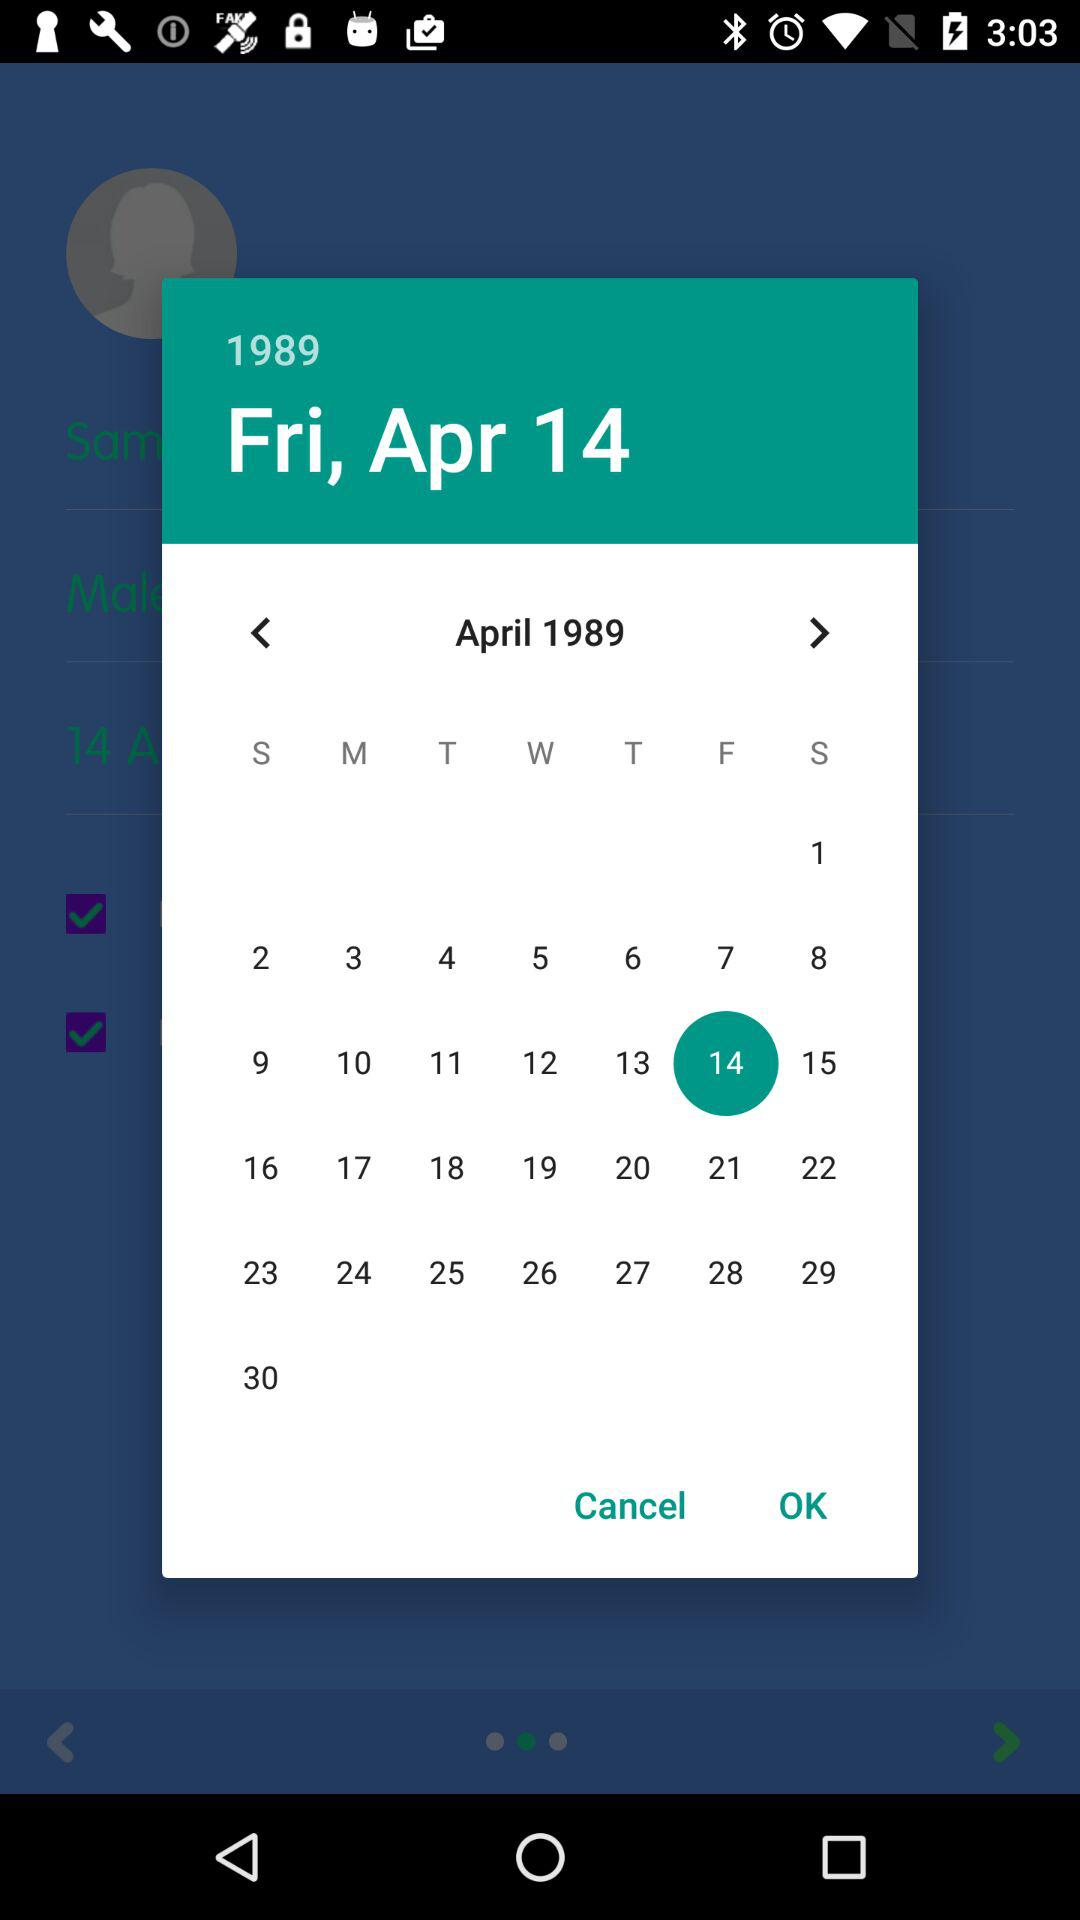What is the selected day? The selected day is Friday. 